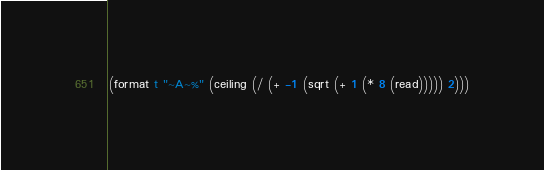<code> <loc_0><loc_0><loc_500><loc_500><_Lisp_>(format t "~A~%" (ceiling (/ (+ -1 (sqrt (+ 1 (* 8 (read))))) 2)))</code> 